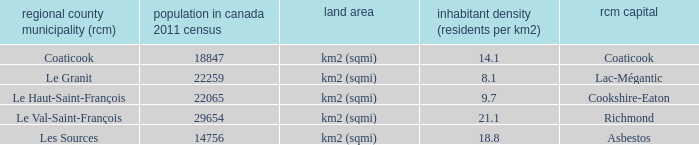What is the seat of the RCM in the county that has a density of 9.7? Cookshire-Eaton. 